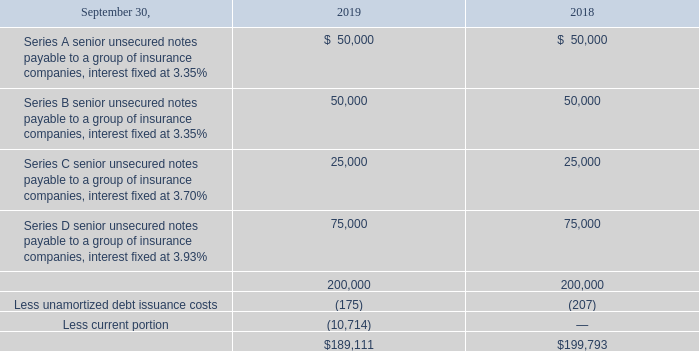NOTE 11—FINANCING ARRANGEMENTS
Long-term debt consists of the following (in thousands):
Maturities of long-term debt for each of the five years in the period ending September 30, 2024, are as follows: 2020 — $10.7 million; 2021 — $35.7 million; 2022 — $35.7 million; 2023 — $35.7 million; 2024 — $35.7 million.
In March 2013, we entered into a note purchase and private shelf agreement pursuant to which we issued $100.0 million of senior unsecured notes, bearing interest at a rate of 3.35% and maturing on March 12, 2025. Pursuant to the agreement, on July 17, 2015, we issued an additional $25.0 million of senior unsecured notes, bearing interest at a rate of 3.70% and maturing on March 12, 2025. Interest payments on the notes issued in 2013 and 2015 are due semi-annually and principal payments are due from 2021 through 2025. On February 2, 2016 we revised the note purchase agreement and we issued an additional $75.0 million of senior unsecured notes bearing interest at 3.93% and maturing on March 12, 2026. Interest payments on these notes are due semi-annually and principal payments are due from 2020 through 2026.
The agreement pertaining to the aforementioned notes also contained a provision that the coupon rate would increase by a further 0.50% should the company’s leverage ratio exceed a certain level.
What is the maturity of long-term debt for 2021? $35.7 million. What are the different series of senior unsecured notes payable to a group of insurance companies? Series a, series b, series c, series d. What are the different interest rates for the different senior unsecured notes payable to a group of insurance companies? 3.35%, 3.70%, 3.93%. Which series of senior unsecured notes payable to a group of insurance companies is fixed at the largest interest rate? 3.93%>3.70%>3.35%
Answer: series d. What is the change in the total amount of long-term debt in 2019 from 2018?
Answer scale should be: thousand. 189,111-199,793
Answer: -10682. What is the percentage change in the total amount of long-term debt in 2019 from 2018?
Answer scale should be: percent. (189,111-199,793)/199,793
Answer: -5.35. 